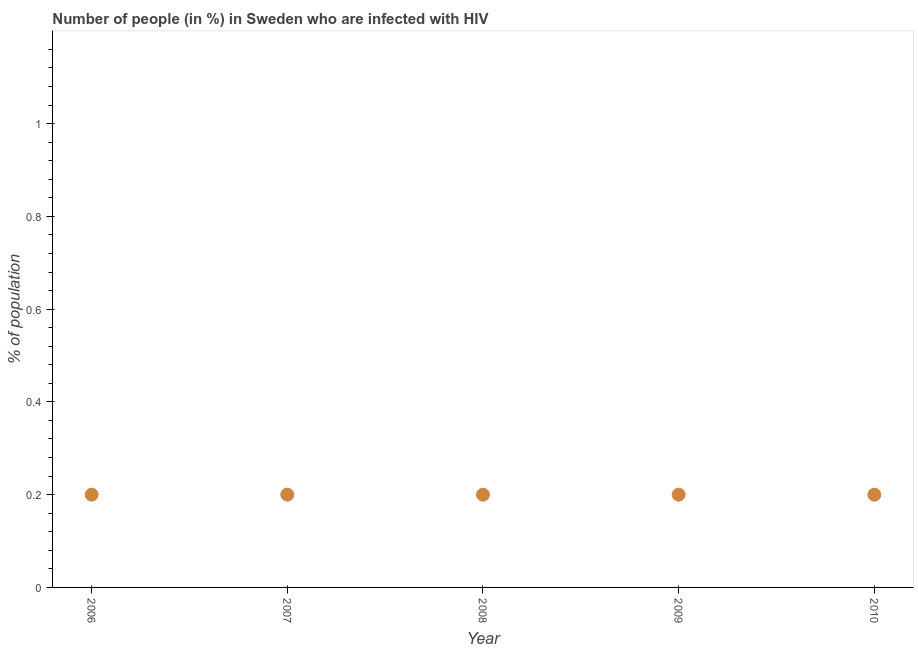What is the number of people infected with hiv in 2007?
Keep it short and to the point. 0.2. Across all years, what is the maximum number of people infected with hiv?
Give a very brief answer. 0.2. Across all years, what is the minimum number of people infected with hiv?
Your answer should be compact. 0.2. In which year was the number of people infected with hiv maximum?
Your response must be concise. 2006. What is the difference between the number of people infected with hiv in 2006 and 2010?
Make the answer very short. 0. What is the median number of people infected with hiv?
Keep it short and to the point. 0.2. In how many years, is the number of people infected with hiv greater than 0.12 %?
Offer a terse response. 5. Is the difference between the number of people infected with hiv in 2006 and 2007 greater than the difference between any two years?
Your response must be concise. Yes. What is the difference between the highest and the second highest number of people infected with hiv?
Provide a succinct answer. 0. Does the number of people infected with hiv monotonically increase over the years?
Ensure brevity in your answer.  No. How many years are there in the graph?
Your answer should be compact. 5. What is the difference between two consecutive major ticks on the Y-axis?
Your response must be concise. 0.2. Does the graph contain any zero values?
Provide a short and direct response. No. What is the title of the graph?
Your answer should be compact. Number of people (in %) in Sweden who are infected with HIV. What is the label or title of the X-axis?
Keep it short and to the point. Year. What is the label or title of the Y-axis?
Make the answer very short. % of population. What is the % of population in 2006?
Provide a succinct answer. 0.2. What is the % of population in 2007?
Your response must be concise. 0.2. What is the % of population in 2008?
Your response must be concise. 0.2. What is the difference between the % of population in 2006 and 2008?
Make the answer very short. 0. What is the difference between the % of population in 2006 and 2009?
Keep it short and to the point. 0. What is the difference between the % of population in 2008 and 2009?
Your answer should be very brief. 0. What is the ratio of the % of population in 2006 to that in 2007?
Make the answer very short. 1. What is the ratio of the % of population in 2006 to that in 2008?
Your answer should be compact. 1. What is the ratio of the % of population in 2006 to that in 2009?
Your answer should be very brief. 1. What is the ratio of the % of population in 2006 to that in 2010?
Provide a short and direct response. 1. What is the ratio of the % of population in 2007 to that in 2009?
Your response must be concise. 1. What is the ratio of the % of population in 2008 to that in 2010?
Your answer should be very brief. 1. 